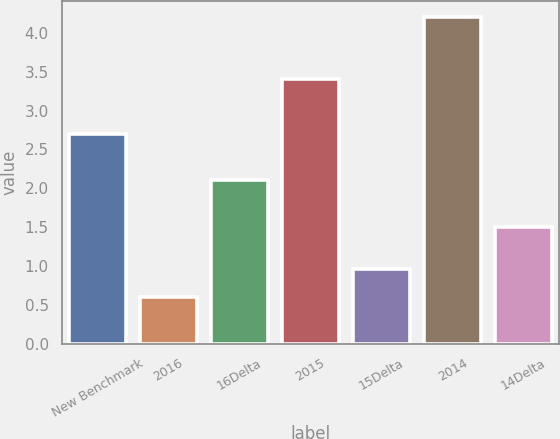Convert chart. <chart><loc_0><loc_0><loc_500><loc_500><bar_chart><fcel>New Benchmark<fcel>2016<fcel>16Delta<fcel>2015<fcel>15Delta<fcel>2014<fcel>14Delta<nl><fcel>2.7<fcel>0.6<fcel>2.1<fcel>3.4<fcel>0.96<fcel>4.2<fcel>1.5<nl></chart> 